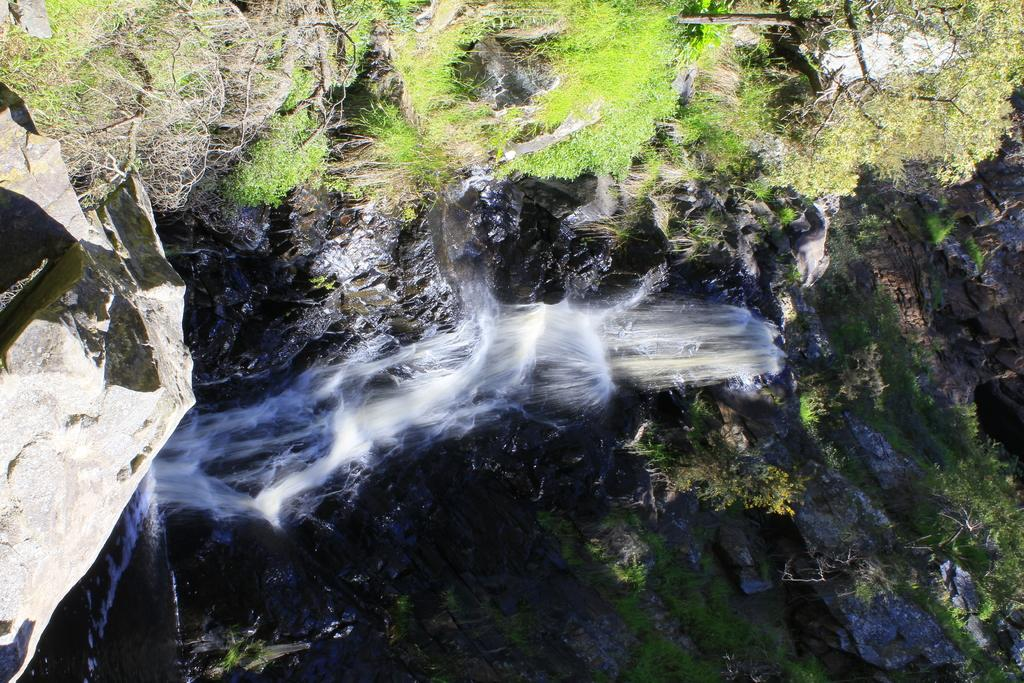What natural feature is the main subject of the image? There is a waterfall in the image. What else can be seen in the image besides the waterfall? There are rocks in the image. What type of vegetation is visible in the background of the image? Trees and grass are present in the background of the image. What color are the trees and grass in the image? The trees and grass are green in color. What type of bait is being used to catch fish in the image? There is no fishing or bait present in the image; it features a waterfall, rocks, and green vegetation. 